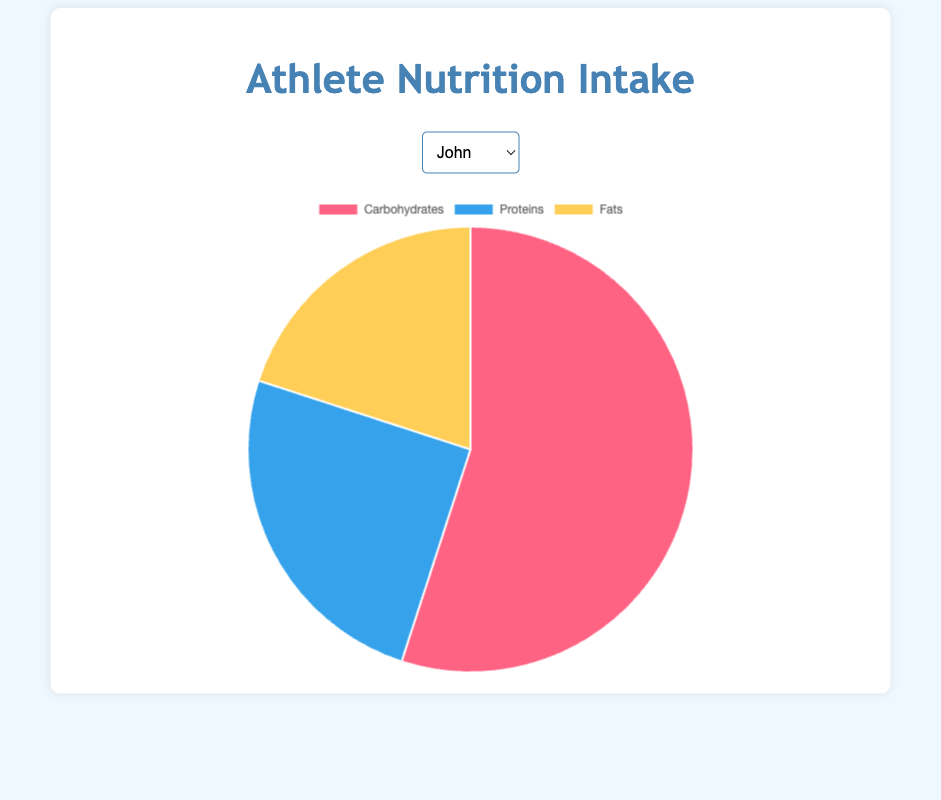what's the ratio of carbohydrates to the total nutrition intake for John? To find the ratio, refer to the nutrition chart. Carbohydrates make up 55g of John's intake out of a total intake of 100g (55g carbohydrates + 25g proteins + 20g fats). The ratio is 55:100 or 11:20 when simplified.
Answer: 11:20 Compare the protein intake of Sarah and Emily. Who intake more? Refer to the pie chart for both Sarah and Emily. Sarah's protein intake is 35g, while Emily's is 30g. Therefore, Sarah's protein intake is higher.
Answer: Sarah For Michael, if his fats intake increases by 10g, what would be the percentage of fats in his nutrition intake? Michael's current fats intake is 20g. If it increases by 10g, the new fats intake is 30g. The total nutrition intake thus becomes 110g (60g carbohydrates + 20g proteins + 30g fats). Therefore, the percentage of fats is (30g/110g) * 100 ≈ 27.27%.
Answer: 27.27% Which athlete has the lowest intake of fats? Compare the fats intake in the pie charts of all athletes. David has the lowest intake with 15g of fats.
Answer: David What’s the total intake of macronutrients for Emily? Refer to Emily's pie chart. The total intake is the sum of all macronutrients: 50g carbohydrates + 30g proteins + 20g fats = 100g.
Answer: 100g If John's carbohydrate amount is redistributed equally into proteins and fats, what would be the new distribution? John's carbohydrates are 55g. If redistributed equally into proteins and fats, each gets (55g/2)= 27.5g. Adding this to the current values: Proteins: 25g + 27.5g = 52.5g, Fats: 20g + 27.5g = 47.5g. Carbohydrates become 0g. The new distribution is 0g carbohydrates, 52.5g proteins, and 47.5g fats.
Answer: Carbohydrates: 0g, Proteins: 52.5g, Fats: 47.5g What is the difference in carbohydrate intake between the athlete with the highest and the one with the lowest intake? David has the highest carbohydrate intake with 65g, and Sarah has the lowest with 45g. The difference is 65g - 45g = 20g.
Answer: 20g Compare the carbohydrates intake of Emily and Michael. Which color represents carbohydrates on their charts? On the pie charts, carbohydrates are represented by the color red. Emily's intake is 50g, and Michael's intake is 60g. Thus, Michael has a higher carbohydrates intake.
Answer: Red, Michael 